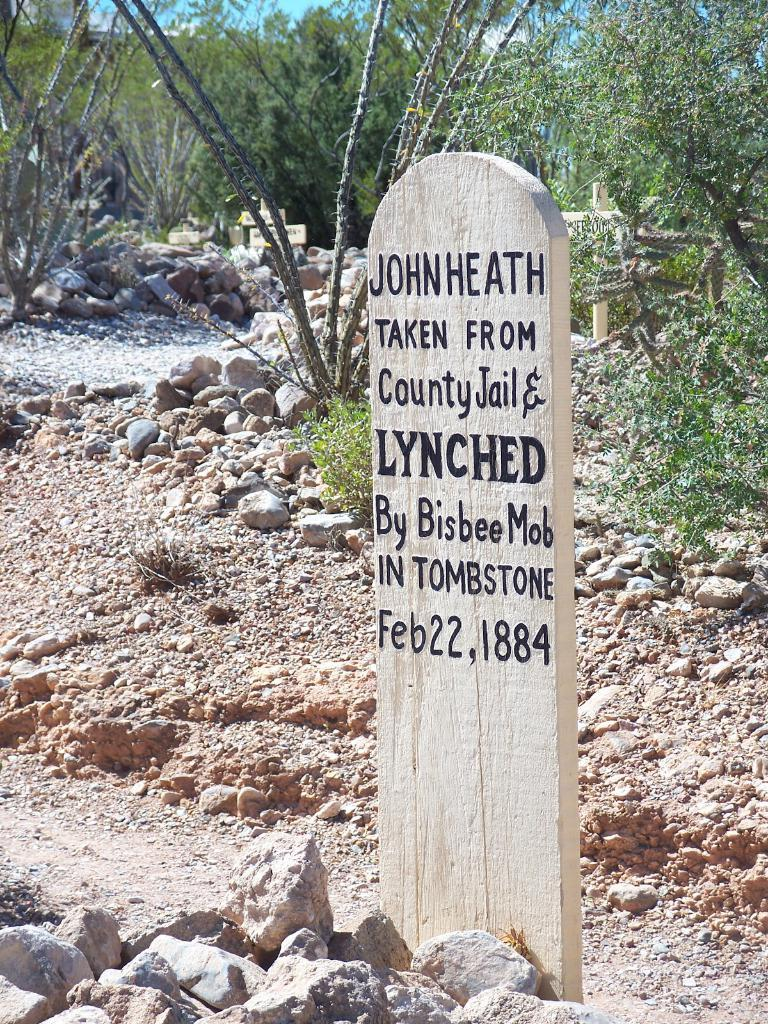What type of location is depicted in the image? There is a cemetery in the image. What can be seen in the background of the image? There are rocks and green trees in the background of the image. What color is the sky in the image? The sky is blue in the image. What type of plant is growing on the back of the cemetery in the image? There is no plant growing on the back of the cemetery in the image, as the concept of "back" is not applicable to a cemetery. 